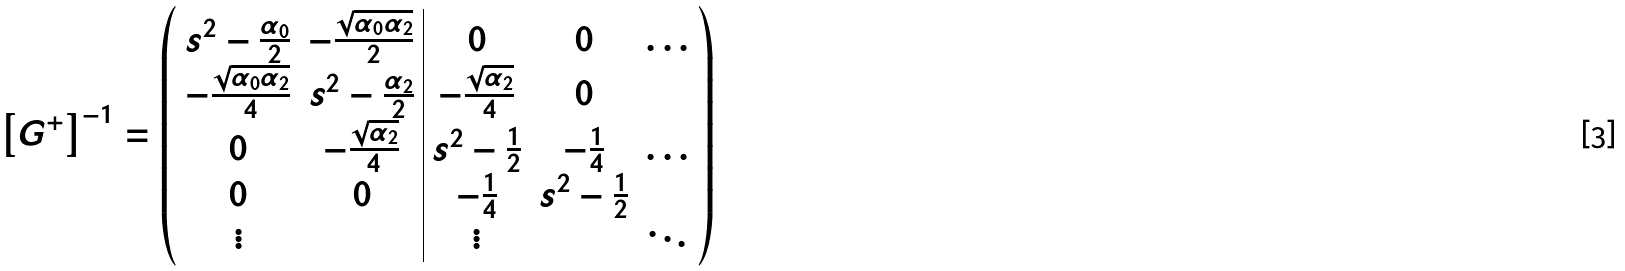<formula> <loc_0><loc_0><loc_500><loc_500>\left [ { G } ^ { + } \right ] ^ { - 1 } = \left ( \begin{array} { c c | c c c } s ^ { 2 } - \frac { \alpha _ { 0 } } { 2 } & - \frac { \sqrt { \alpha _ { 0 } \alpha _ { 2 } } } { 2 } & 0 & 0 & \dots \\ - \frac { \sqrt { \alpha _ { 0 } \alpha _ { 2 } } } { 4 } & s ^ { 2 } - \frac { \alpha _ { 2 } } { 2 } & - \frac { \sqrt { \alpha _ { 2 } } } { 4 } & 0 & \\ 0 & - \frac { \sqrt { \alpha _ { 2 } } } { 4 } & s ^ { 2 } - \frac { 1 } { 2 } & - \frac { 1 } { 4 } & \dots \\ 0 & 0 & - \frac { 1 } { 4 } & s ^ { 2 } - \frac { 1 } { 2 } & \\ \vdots & & \vdots & & \ddots \end{array} \right )</formula> 